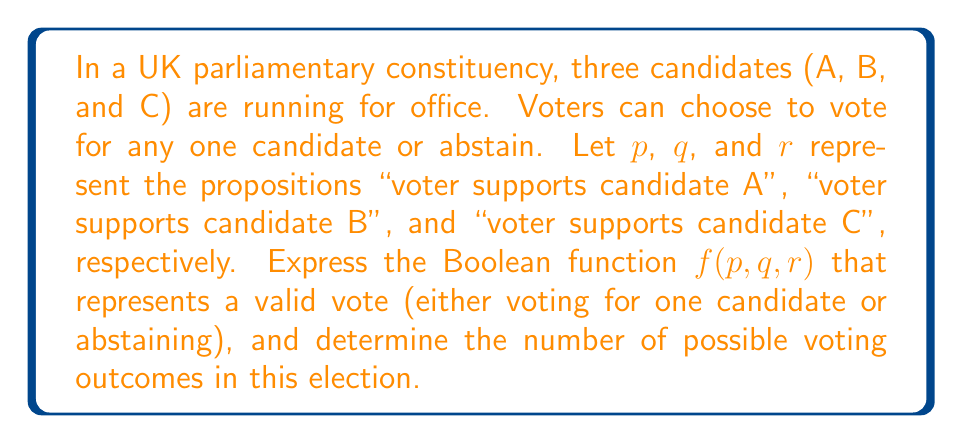Give your solution to this math problem. To solve this problem, we'll follow these steps:

1. Express the Boolean function for a valid vote:
   A valid vote is one where a voter either chooses one candidate or abstains. We can express this as:

   $f(p,q,r) = (p \land \lnot q \land \lnot r) \lor (\lnot p \land q \land \lnot r) \lor (\lnot p \land \lnot q \land r) \lor (\lnot p \land \lnot q \land \lnot r)$

   This function is true when exactly one variable is true (voting for one candidate) or when all variables are false (abstaining).

2. Simplify the function:
   We can simplify this function to:

   $f(p,q,r) = p \oplus q \oplus r \oplus (p \land q \land r)$

   Where $\oplus$ represents the XOR operation.

3. Determine the number of possible voting outcomes:
   To find the number of possible outcomes, we need to count the number of combinations that make the function true.

   - Voting for A: $(1,0,0)$
   - Voting for B: $(0,1,0)$
   - Voting for C: $(0,0,1)$
   - Abstaining: $(0,0,0)$

   There are 4 possible outcomes that satisfy the Boolean function.

4. Verify using a truth table:
   We can verify this by creating a truth table for $f(p,q,r)$:

   | $p$ | $q$ | $r$ | $f(p,q,r)$ |
   |-----|-----|-----|------------|
   | 0   | 0   | 0   | 1          |
   | 0   | 0   | 1   | 1          |
   | 0   | 1   | 0   | 1          |
   | 0   | 1   | 1   | 0          |
   | 1   | 0   | 0   | 1          |
   | 1   | 0   | 1   | 0          |
   | 1   | 1   | 0   | 0          |
   | 1   | 1   | 1   | 0          |

   The truth table confirms that there are 4 rows where $f(p,q,r) = 1$, corresponding to the 4 valid voting outcomes.
Answer: 4 